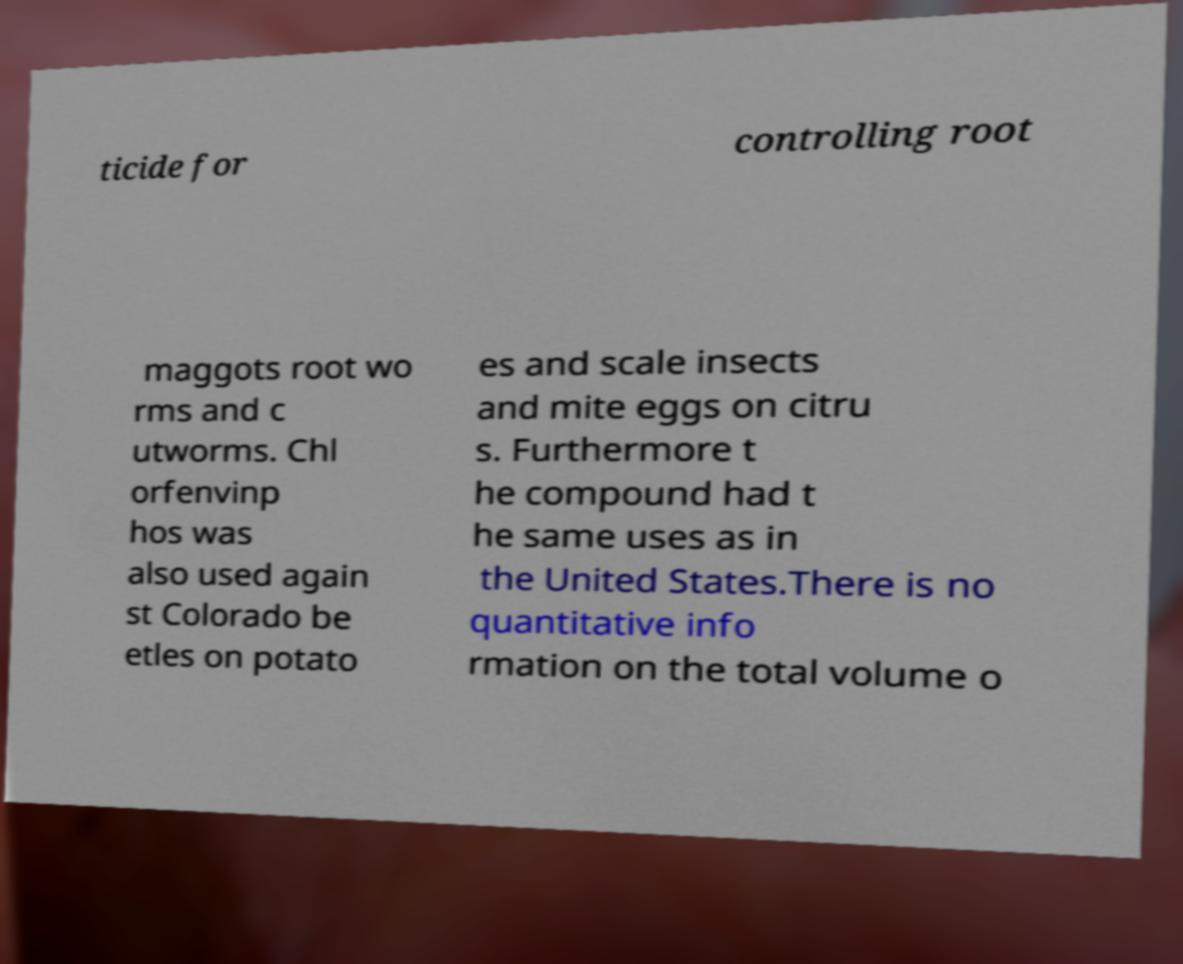Can you read and provide the text displayed in the image?This photo seems to have some interesting text. Can you extract and type it out for me? ticide for controlling root maggots root wo rms and c utworms. Chl orfenvinp hos was also used again st Colorado be etles on potato es and scale insects and mite eggs on citru s. Furthermore t he compound had t he same uses as in the United States.There is no quantitative info rmation on the total volume o 